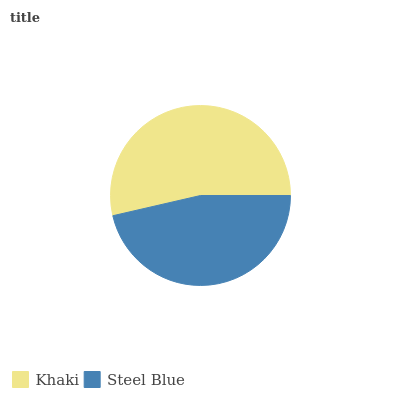Is Steel Blue the minimum?
Answer yes or no. Yes. Is Khaki the maximum?
Answer yes or no. Yes. Is Steel Blue the maximum?
Answer yes or no. No. Is Khaki greater than Steel Blue?
Answer yes or no. Yes. Is Steel Blue less than Khaki?
Answer yes or no. Yes. Is Steel Blue greater than Khaki?
Answer yes or no. No. Is Khaki less than Steel Blue?
Answer yes or no. No. Is Khaki the high median?
Answer yes or no. Yes. Is Steel Blue the low median?
Answer yes or no. Yes. Is Steel Blue the high median?
Answer yes or no. No. Is Khaki the low median?
Answer yes or no. No. 